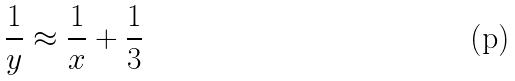<formula> <loc_0><loc_0><loc_500><loc_500>\frac { 1 } { y } \approx \frac { 1 } { x } + \frac { 1 } { 3 }</formula> 